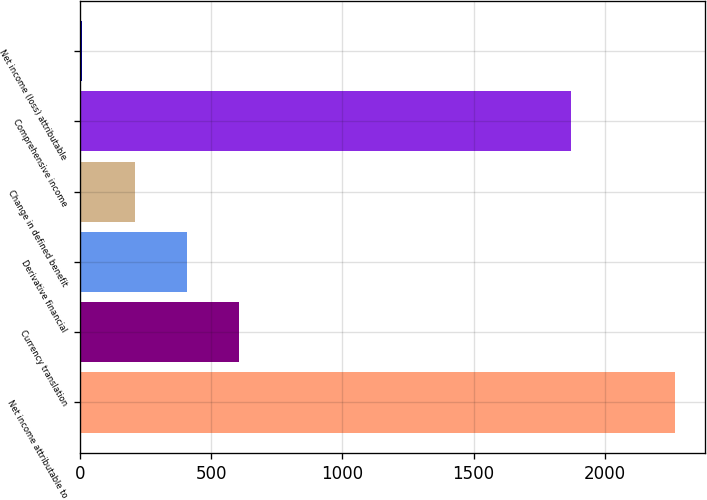Convert chart. <chart><loc_0><loc_0><loc_500><loc_500><bar_chart><fcel>Net income attributable to<fcel>Currency translation<fcel>Derivative financial<fcel>Change in defined benefit<fcel>Comprehensive income<fcel>Net income (loss) attributable<nl><fcel>2268<fcel>604.5<fcel>406<fcel>207.5<fcel>1871<fcel>9<nl></chart> 